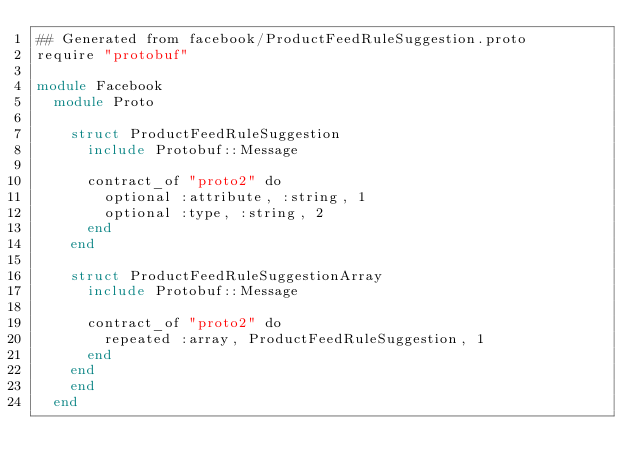<code> <loc_0><loc_0><loc_500><loc_500><_Crystal_>## Generated from facebook/ProductFeedRuleSuggestion.proto
require "protobuf"

module Facebook
  module Proto
    
    struct ProductFeedRuleSuggestion
      include Protobuf::Message
      
      contract_of "proto2" do
        optional :attribute, :string, 1
        optional :type, :string, 2
      end
    end
    
    struct ProductFeedRuleSuggestionArray
      include Protobuf::Message
      
      contract_of "proto2" do
        repeated :array, ProductFeedRuleSuggestion, 1
      end
    end
    end
  end
</code> 